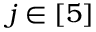<formula> <loc_0><loc_0><loc_500><loc_500>j \in [ 5 ]</formula> 